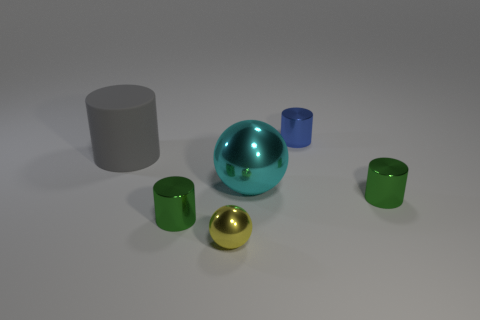How many green cylinders must be subtracted to get 1 green cylinders? 1 Subtract all red spheres. How many green cylinders are left? 2 Subtract all blue cylinders. How many cylinders are left? 3 Subtract all big rubber cylinders. How many cylinders are left? 3 Subtract all purple cylinders. Subtract all red balls. How many cylinders are left? 4 Add 1 small cyan metal blocks. How many objects exist? 7 Subtract all cylinders. How many objects are left? 2 Add 5 big gray objects. How many big gray objects exist? 6 Subtract 0 red blocks. How many objects are left? 6 Subtract all spheres. Subtract all tiny green metallic cylinders. How many objects are left? 2 